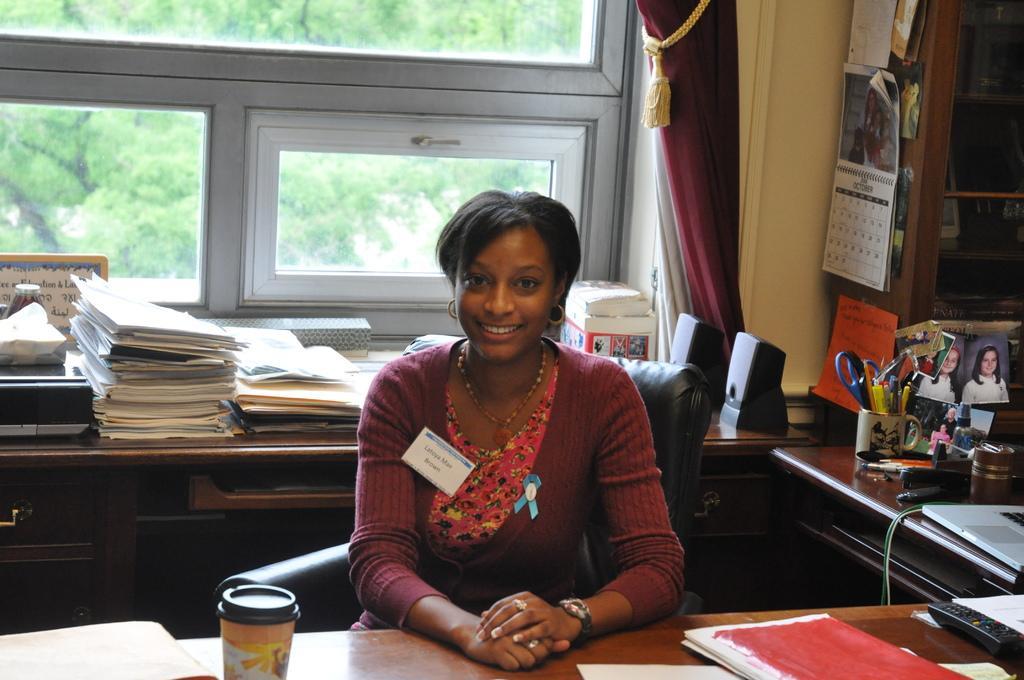Please provide a concise description of this image. In this image we can see a woman is sitting on the chair at the table. On the table we can see books, papers, remote and a cup. In the background there are files, papers, speakers, pens and scissors in a cup and objects on the cupboard table and we can see curtain, wall, windows, calendar and papers on the rack stand. Through the window glasses we can see the trees. 